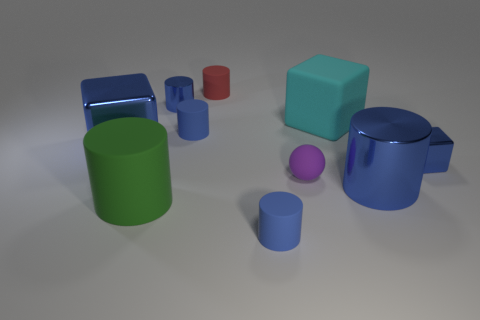Are there more big cylinders that are behind the small purple matte object than cyan things that are on the left side of the green matte cylinder?
Keep it short and to the point. No. What number of large blocks are on the right side of the big blue thing that is right of the sphere?
Your answer should be compact. 0. Are there any rubber things that have the same color as the large rubber block?
Your response must be concise. No. Is the purple rubber ball the same size as the green rubber cylinder?
Provide a short and direct response. No. Is the color of the tiny shiny block the same as the sphere?
Offer a very short reply. No. There is a green thing in front of the blue block to the right of the big green rubber object; what is its material?
Ensure brevity in your answer.  Rubber. There is a tiny red object that is the same shape as the green object; what is its material?
Offer a terse response. Rubber. There is a rubber thing on the right side of the purple thing; does it have the same size as the large blue cylinder?
Offer a terse response. Yes. What number of metal objects are either green things or blocks?
Offer a terse response. 2. The large thing that is to the left of the small red rubber cylinder and to the right of the large metal cube is made of what material?
Ensure brevity in your answer.  Rubber. 